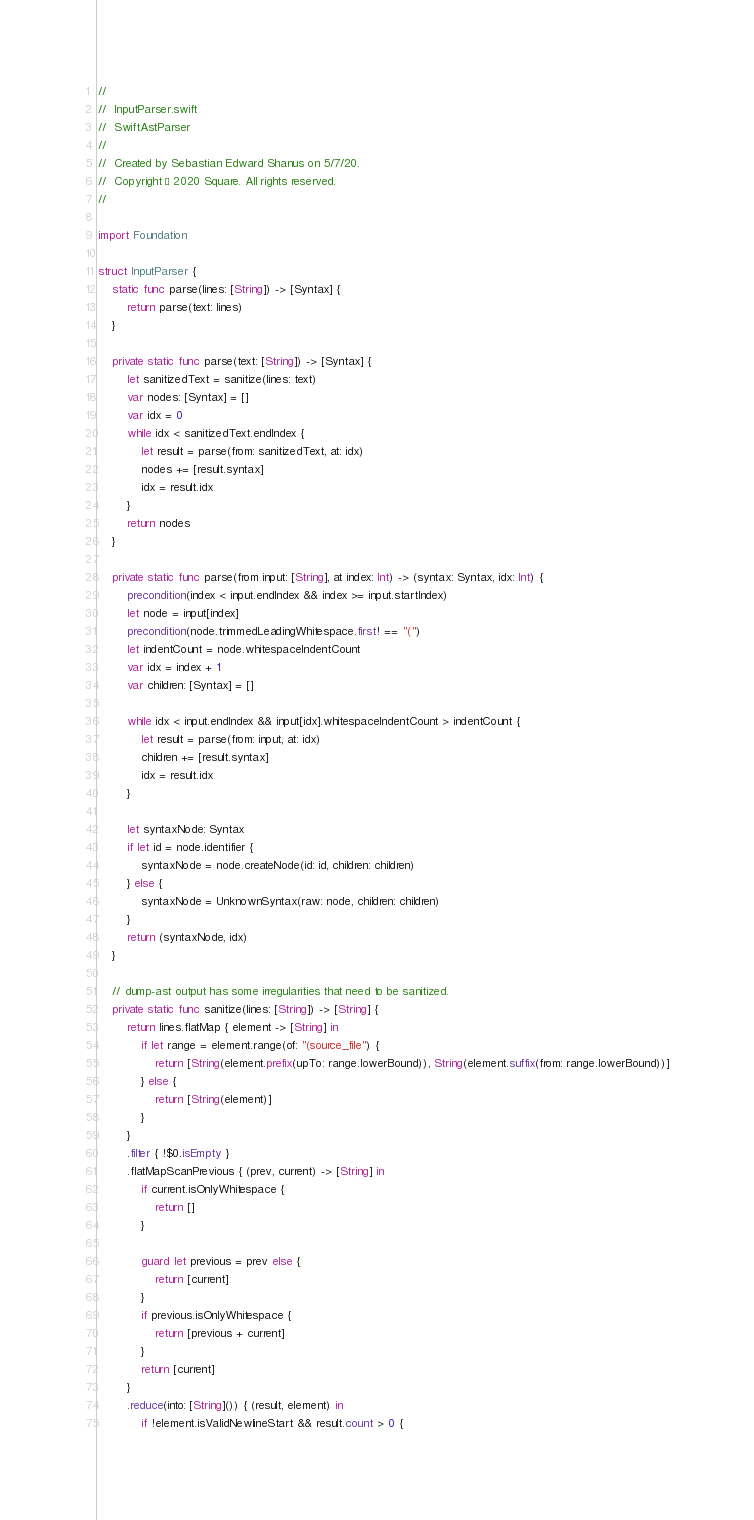Convert code to text. <code><loc_0><loc_0><loc_500><loc_500><_Swift_>//
//  InputParser.swift
//  SwiftAstParser
//
//  Created by Sebastian Edward Shanus on 5/7/20.
//  Copyright © 2020 Square. All rights reserved.
//

import Foundation

struct InputParser {
    static func parse(lines: [String]) -> [Syntax] {
        return parse(text: lines)
    }
    
    private static func parse(text: [String]) -> [Syntax] {
        let sanitizedText = sanitize(lines: text)
        var nodes: [Syntax] = []
        var idx = 0
        while idx < sanitizedText.endIndex {
            let result = parse(from: sanitizedText, at: idx)
            nodes += [result.syntax]
            idx = result.idx
        }
        return nodes
    }
    
    private static func parse(from input: [String], at index: Int) -> (syntax: Syntax, idx: Int) {
        precondition(index < input.endIndex && index >= input.startIndex)
        let node = input[index]
        precondition(node.trimmedLeadingWhitespace.first! == "(")
        let indentCount = node.whitespaceIndentCount
        var idx = index + 1
        var children: [Syntax] = []
        
        while idx < input.endIndex && input[idx].whitespaceIndentCount > indentCount {
            let result = parse(from: input, at: idx)
            children += [result.syntax]
            idx = result.idx
        }
        
        let syntaxNode: Syntax
        if let id = node.identifier {
            syntaxNode = node.createNode(id: id, children: children)
        } else {
            syntaxNode = UnknownSyntax(raw: node, children: children)
        }
        return (syntaxNode, idx)
    }
    
    // dump-ast output has some irregularities that need to be sanitized.
    private static func sanitize(lines: [String]) -> [String] {
        return lines.flatMap { element -> [String] in
            if let range = element.range(of: "(source_file") {
                return [String(element.prefix(upTo: range.lowerBound)), String(element.suffix(from: range.lowerBound))]
            } else {
                return [String(element)]
            }
        }
        .filter { !$0.isEmpty }
        .flatMapScanPrevious { (prev, current) -> [String] in
            if current.isOnlyWhitespace {
                return []
            }
            
            guard let previous = prev else {
                return [current]
            }
            if previous.isOnlyWhitespace {
                return [previous + current]
            }
            return [current]
        }
        .reduce(into: [String]()) { (result, element) in
            if !element.isValidNewlineStart && result.count > 0 {</code> 